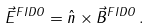<formula> <loc_0><loc_0><loc_500><loc_500>\vec { E } ^ { F I D O } _ { \| } = \hat { n } \times \vec { B } ^ { F I D O } _ { \| } \, .</formula> 